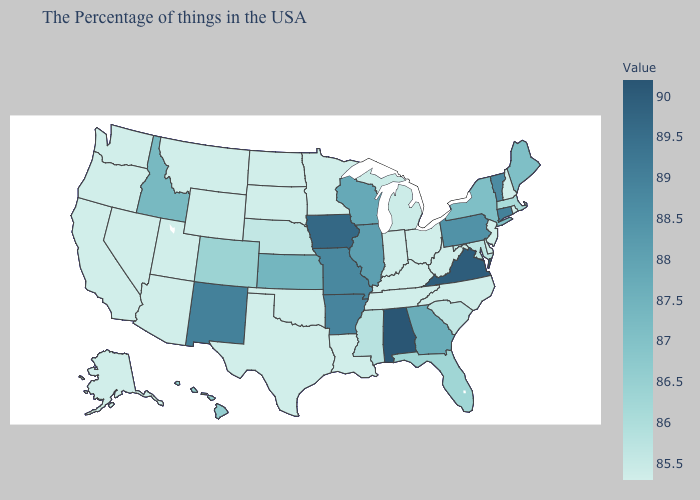Does Wyoming have the lowest value in the West?
Write a very short answer. Yes. Does Connecticut have the highest value in the Northeast?
Short answer required. Yes. 